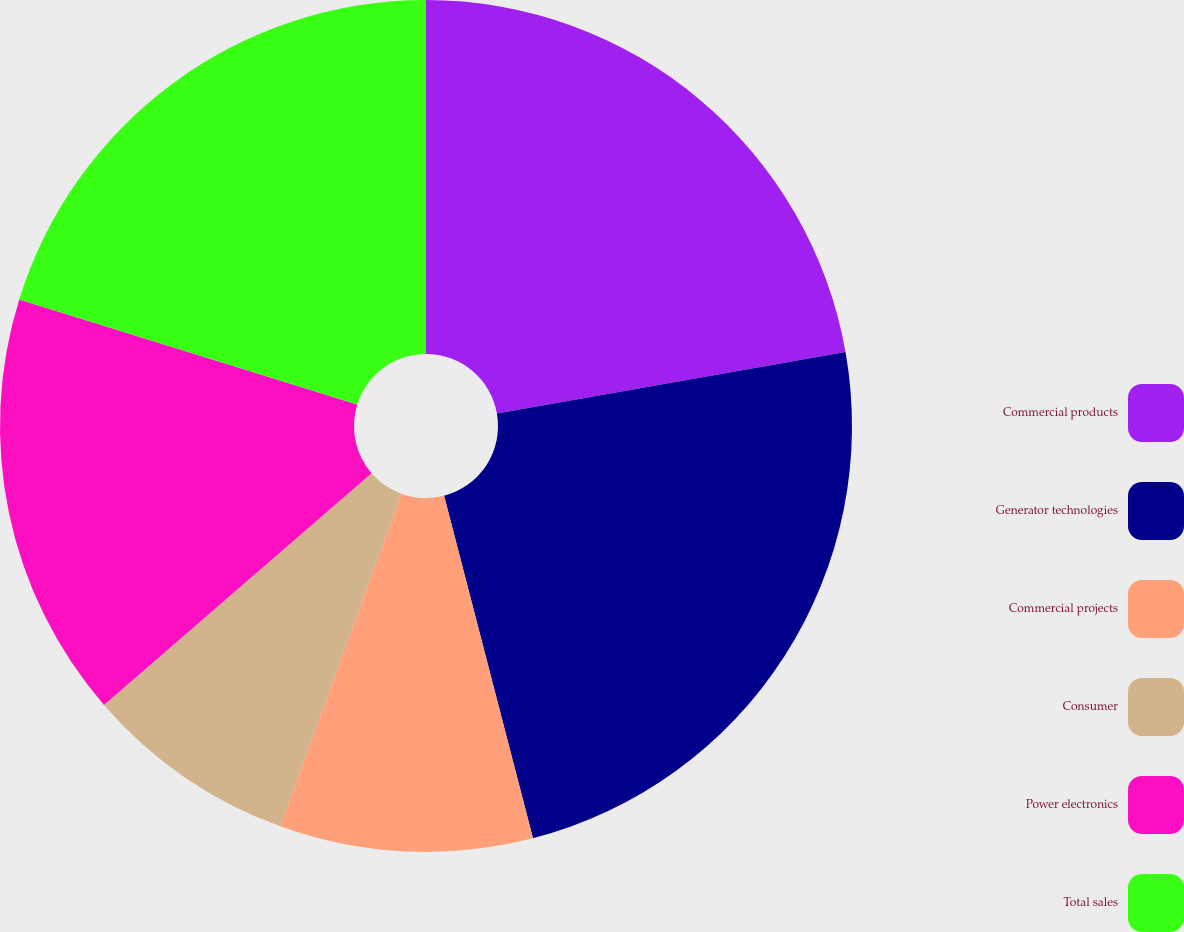Convert chart. <chart><loc_0><loc_0><loc_500><loc_500><pie_chart><fcel>Commercial products<fcel>Generator technologies<fcel>Commercial projects<fcel>Consumer<fcel>Power electronics<fcel>Total sales<nl><fcel>22.22%<fcel>23.74%<fcel>9.6%<fcel>8.08%<fcel>16.16%<fcel>20.2%<nl></chart> 